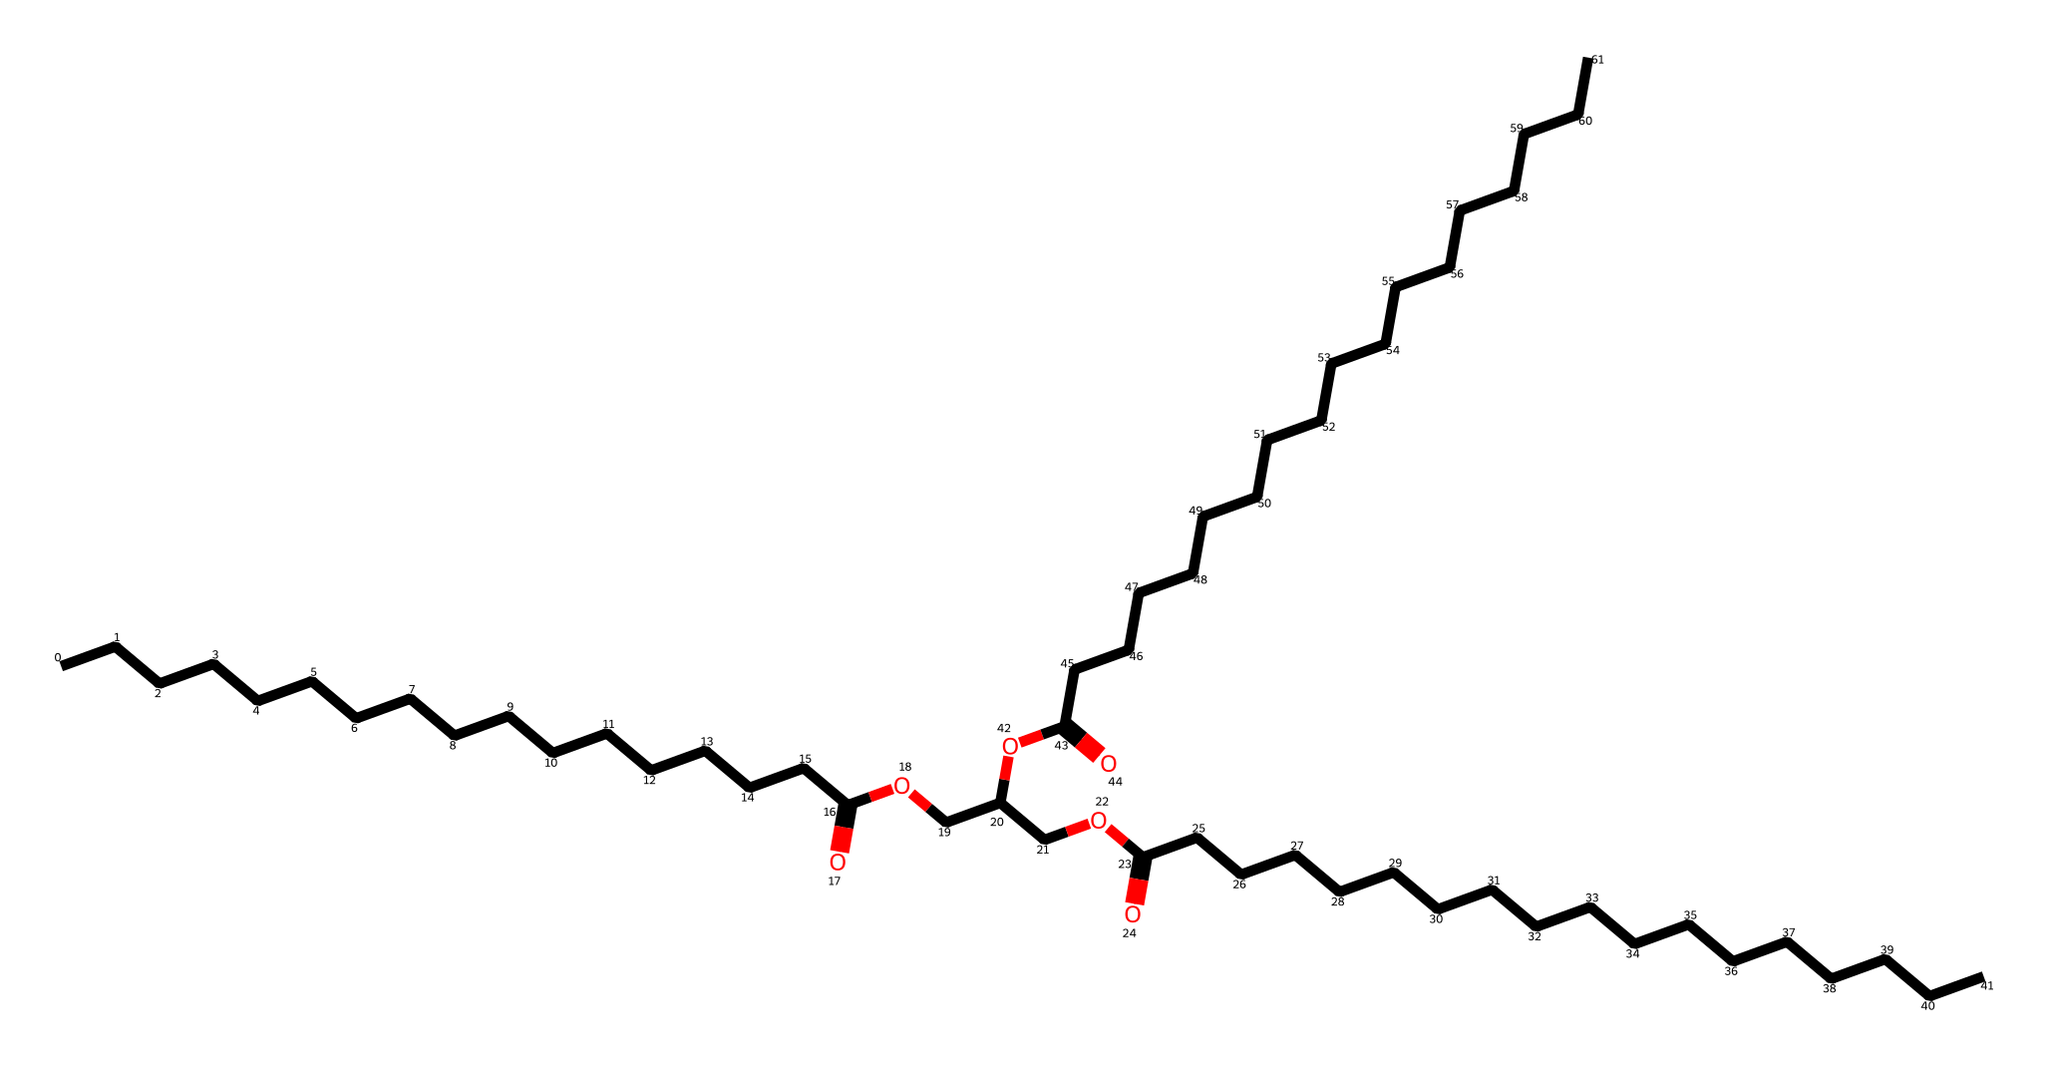How many carbon atoms are in this molecule? By analyzing the SMILES representation, we count the number of "C" characters, which represent carbon atoms. Each "C" counts as one carbon atom, and the total in this structure is 30.
Answer: 30 What functional groups are present in this chemical? Looking at the SMILES, we see "O" and "C(=O)" indicating the presence of ester (RC(=O)O) and carboxylic acid (RCOOH) functional groups. The chemical includes ester linkages as part of its structure.
Answer: ester and carboxylic acid What type of lubricant is represented by this chemical structure? The long carbon chains and multiple ester linkages suggest this compound is a synthetic lubricant commonly used for its stability and low volatility, suitable for extreme conditions like water sports.
Answer: synthetic lubricant What is the molecular weight of this compound? To calculate the molecular weight, we must account for the individual atomic weights of carbon, hydrogen, and oxygen found in the structure. After summing these weights based on the number of each type of atom (30 carbons, 60 hydrogens, and 6 oxygens), we find the total is approximately 462 g/mol.
Answer: 462 g/mol How many ester linkages are in this molecule? The presence of "OC(=O)" or "C(=O)O" repeatedly in the SMILES indicates the number of ester linkages. By identifying these segments in the structure, we count three distinct ester groups.
Answer: 3 